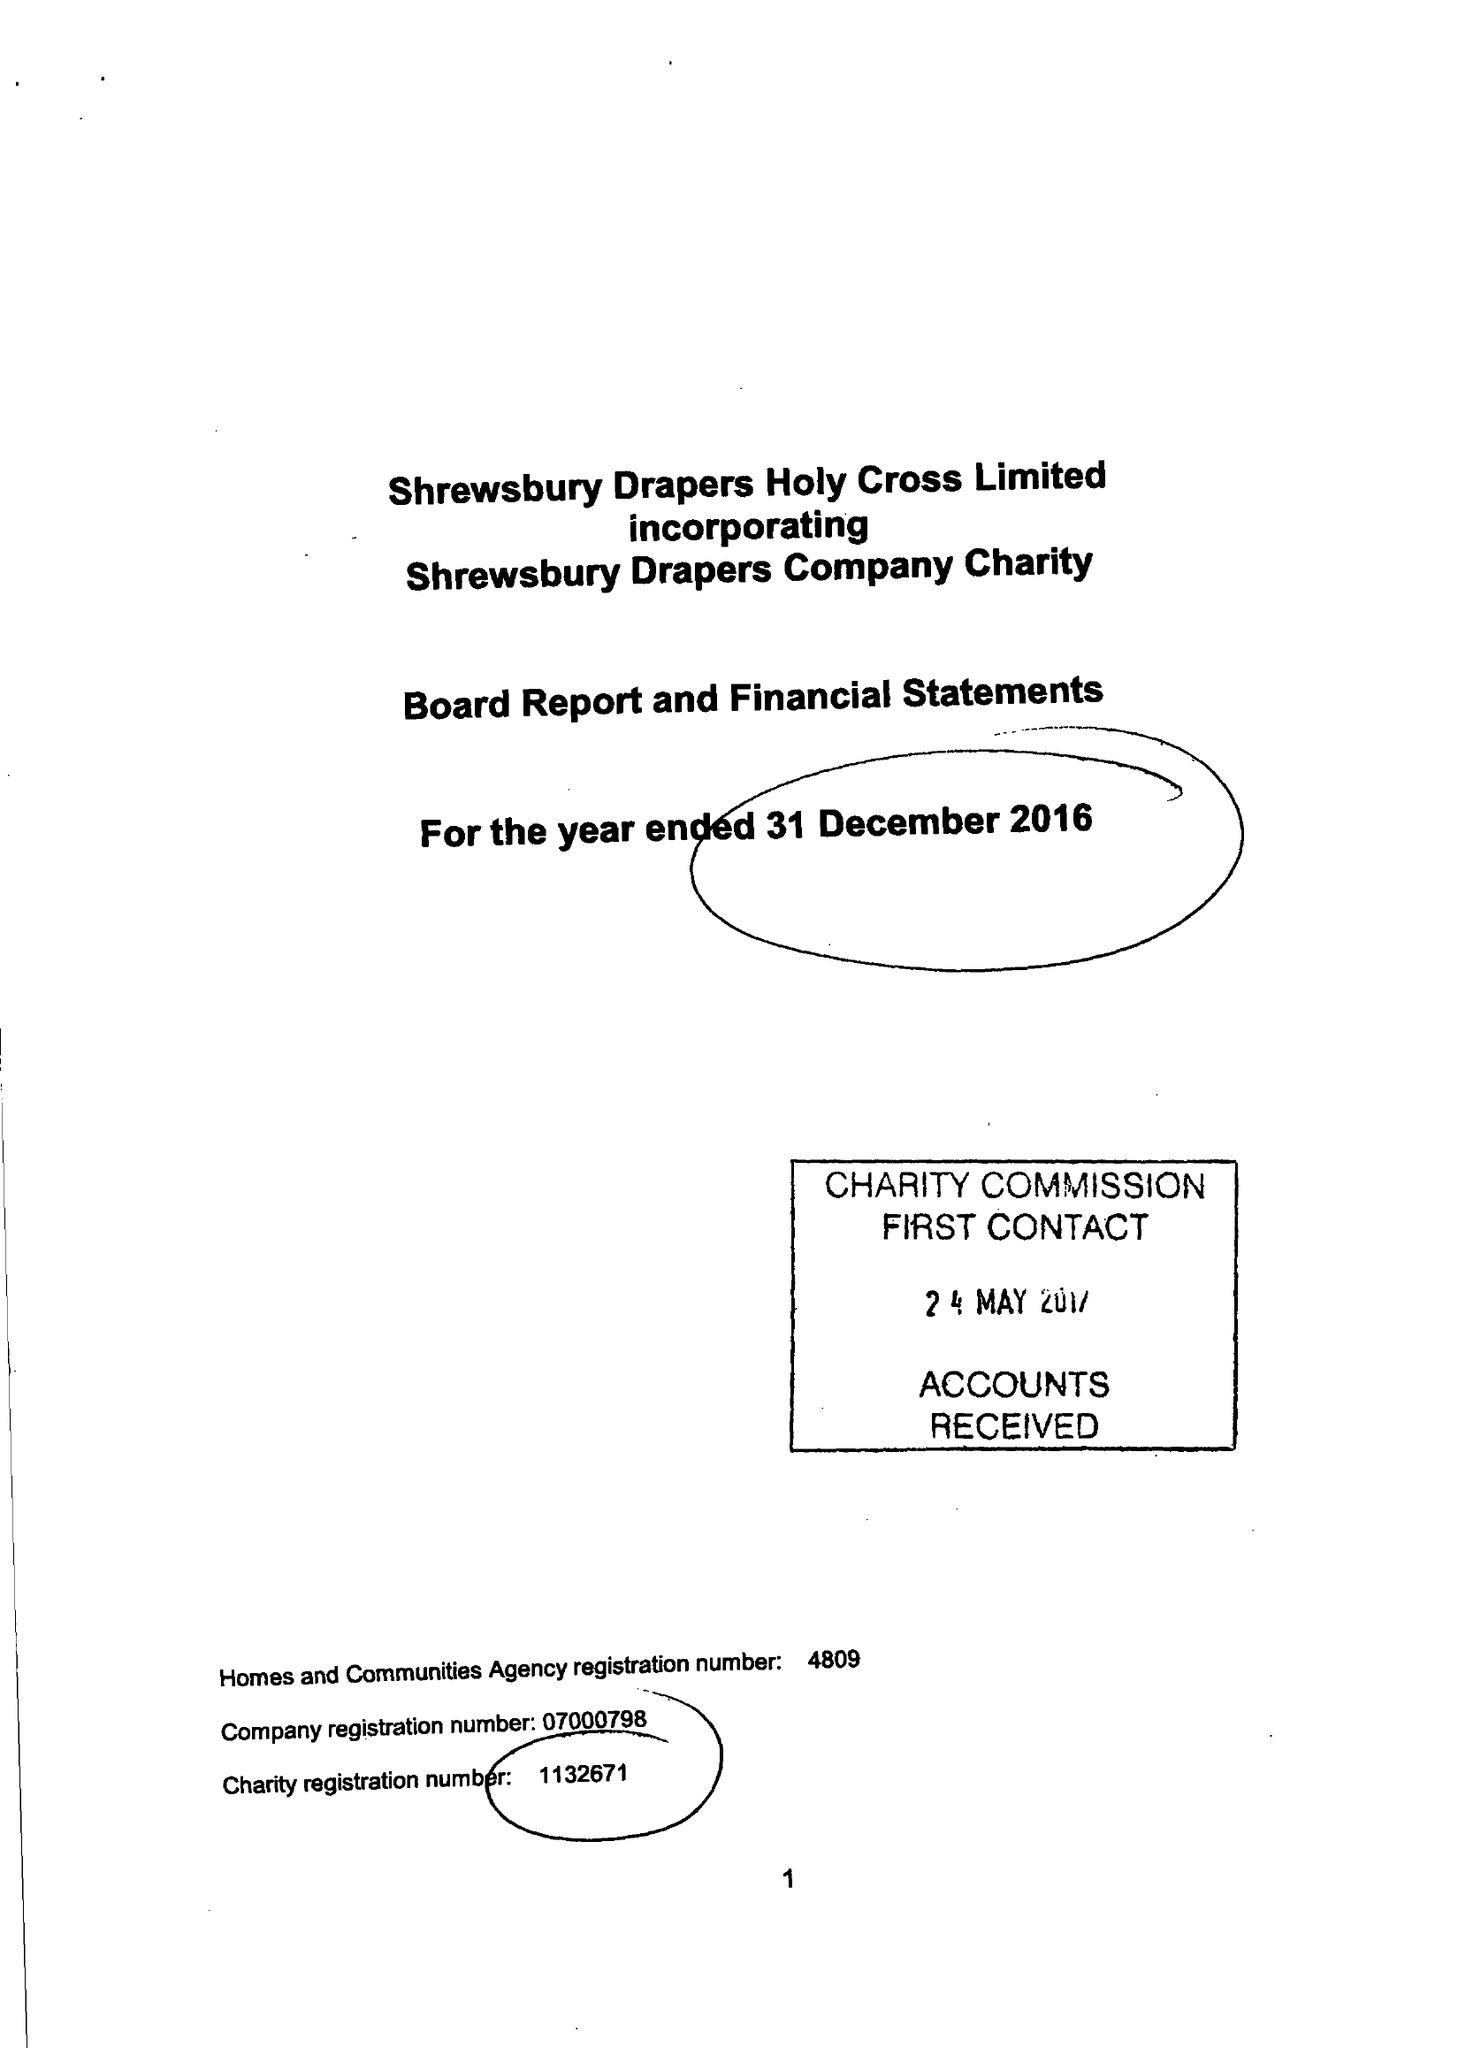What is the value for the report_date?
Answer the question using a single word or phrase. 2016-12-31 